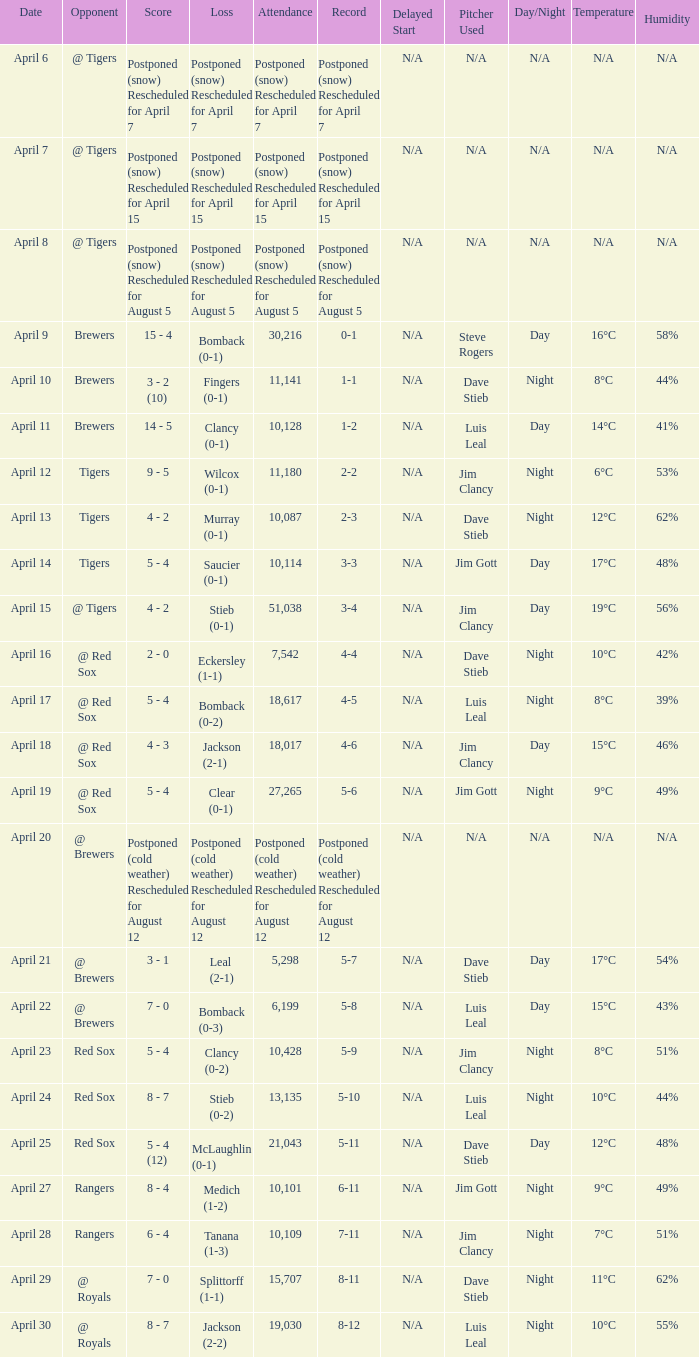Which record is dated April 8? Postponed (snow) Rescheduled for August 5. 